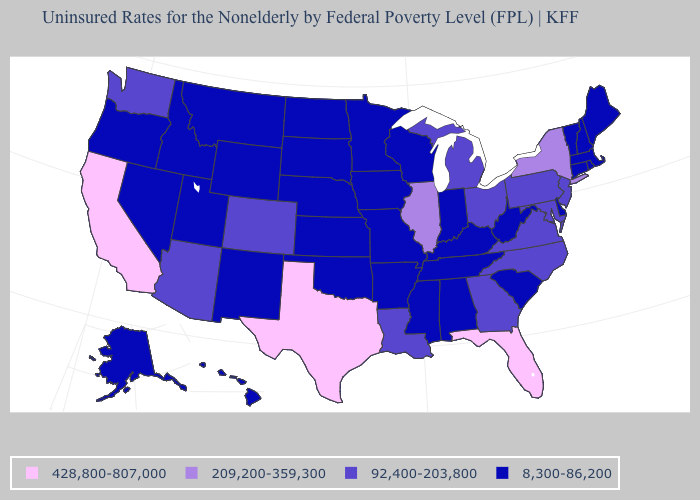What is the value of Nebraska?
Write a very short answer. 8,300-86,200. Name the states that have a value in the range 428,800-807,000?
Give a very brief answer. California, Florida, Texas. Does the first symbol in the legend represent the smallest category?
Be succinct. No. What is the value of Idaho?
Quick response, please. 8,300-86,200. How many symbols are there in the legend?
Write a very short answer. 4. Name the states that have a value in the range 92,400-203,800?
Give a very brief answer. Arizona, Colorado, Georgia, Louisiana, Maryland, Michigan, New Jersey, North Carolina, Ohio, Pennsylvania, Virginia, Washington. Which states hav the highest value in the MidWest?
Concise answer only. Illinois. What is the highest value in the USA?
Write a very short answer. 428,800-807,000. Does New Mexico have a lower value than Michigan?
Short answer required. Yes. How many symbols are there in the legend?
Quick response, please. 4. Does Kansas have the highest value in the USA?
Answer briefly. No. What is the lowest value in the Northeast?
Quick response, please. 8,300-86,200. Name the states that have a value in the range 209,200-359,300?
Answer briefly. Illinois, New York. Name the states that have a value in the range 209,200-359,300?
Be succinct. Illinois, New York. What is the highest value in states that border Iowa?
Keep it brief. 209,200-359,300. 